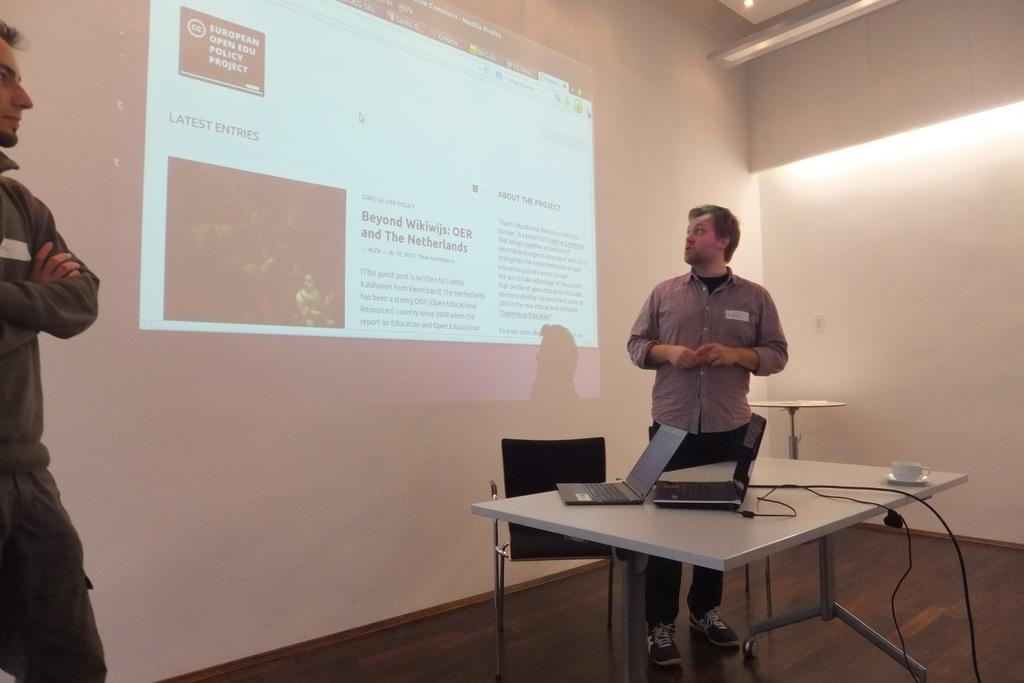How many men are present in the image? There are two men standing in the image. What objects can be seen on the table? There are two laptops, a wire, a cup, and a saucer on the table. What type of furniture is in the image? There is a chair in the image. What sources of light are visible in the image? There is a light in the image. What type of screen is present in the image? There is a screen in the image. What type of range is visible in the image? There is no range present in the image. What type of pipe can be seen in the image? There is no pipe present in the image. 